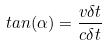Convert formula to latex. <formula><loc_0><loc_0><loc_500><loc_500>t a n ( \alpha ) = \frac { v \delta t } { c \delta t }</formula> 